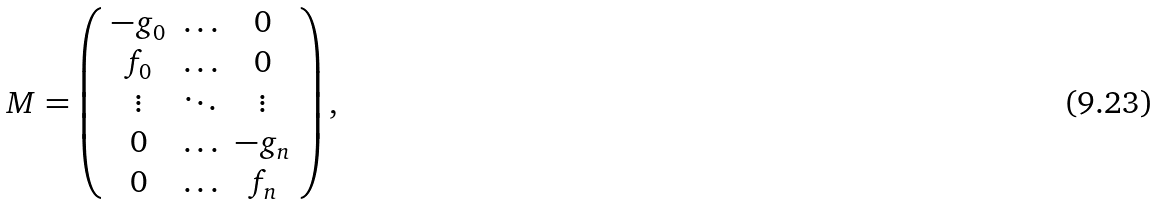Convert formula to latex. <formula><loc_0><loc_0><loc_500><loc_500>M = \left ( \begin{array} { c c c } - g _ { 0 } & \hdots & 0 \\ f _ { 0 } & \hdots & 0 \\ \vdots & \ddots & \vdots \\ 0 & \hdots & - g _ { n } \\ 0 & \hdots & f _ { n } \end{array} \right ) ,</formula> 